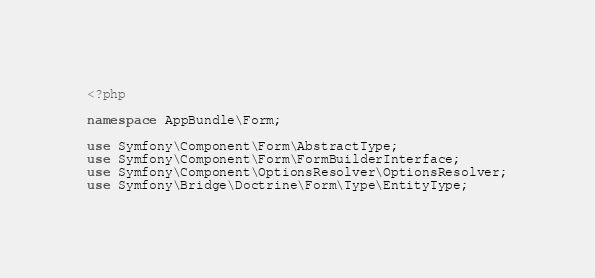<code> <loc_0><loc_0><loc_500><loc_500><_PHP_><?php

namespace AppBundle\Form;

use Symfony\Component\Form\AbstractType;
use Symfony\Component\Form\FormBuilderInterface;
use Symfony\Component\OptionsResolver\OptionsResolver;
use Symfony\Bridge\Doctrine\Form\Type\EntityType;</code> 